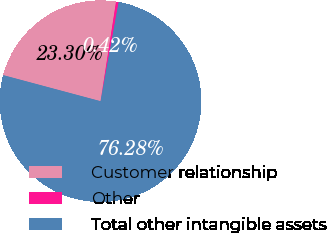<chart> <loc_0><loc_0><loc_500><loc_500><pie_chart><fcel>Customer relationship<fcel>Other<fcel>Total other intangible assets<nl><fcel>23.3%<fcel>0.42%<fcel>76.28%<nl></chart> 